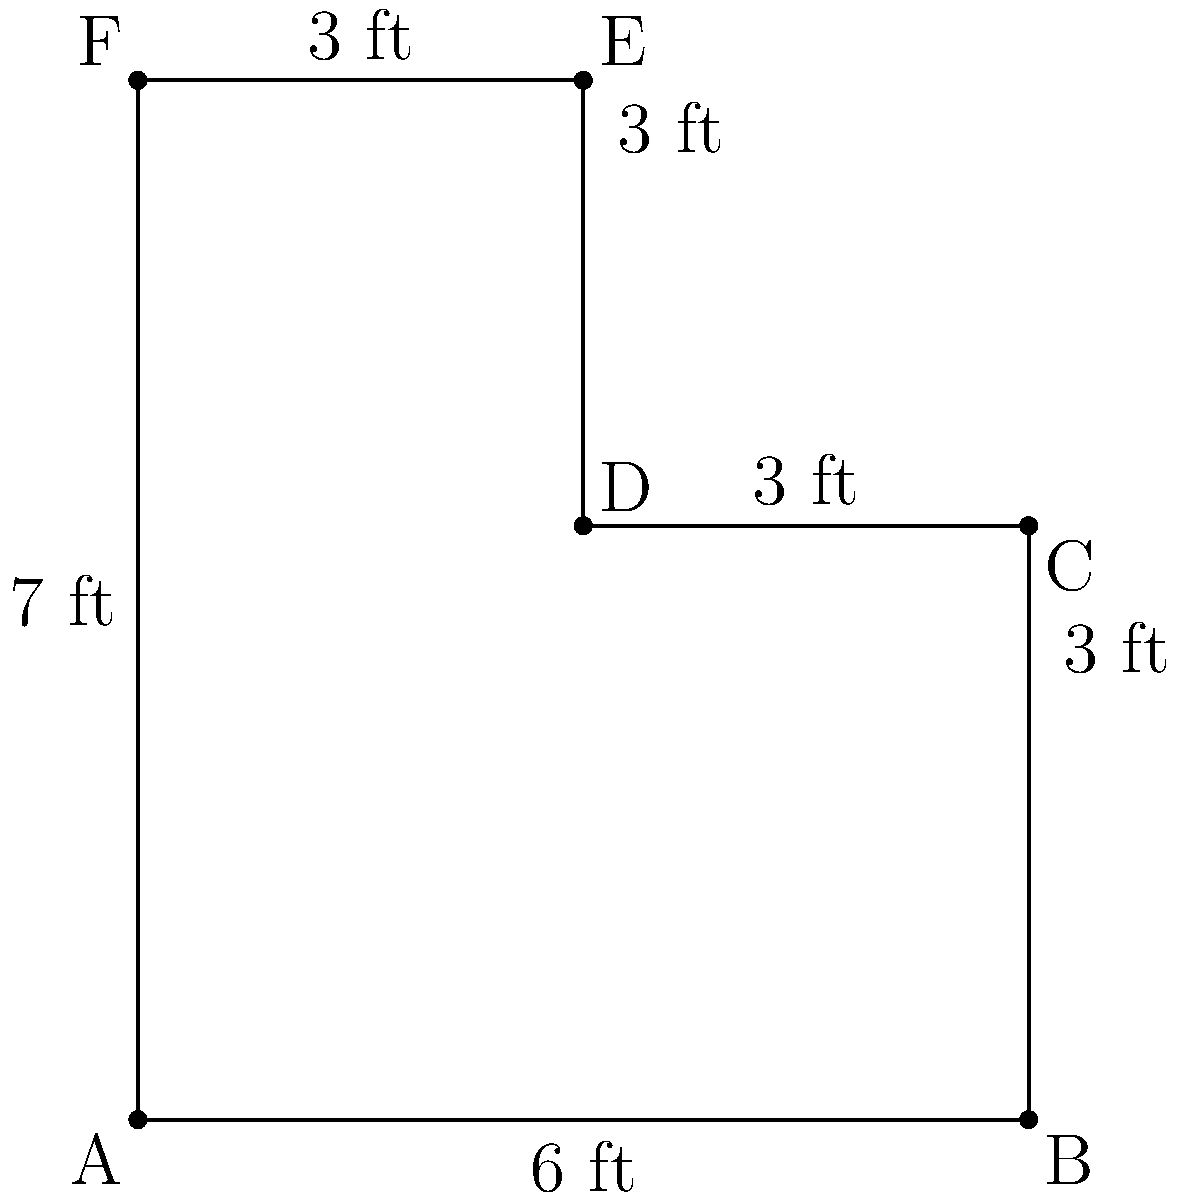You're designing an L-shaped editing desk for your filmography projects. The desk has the dimensions shown in the diagram. Calculate the perimeter of the desk to determine how much LED strip lighting you'll need to outline its edge. To find the perimeter of the L-shaped desk, we need to sum up all the outer edge lengths:

1. Start from point A and move clockwise:
   AB = 6 ft
   BC = 3 ft
   CD = 3 ft
   DE = 3 ft
   EF = 3 ft
   FA = 7 ft

2. Add all these lengths:
   Perimeter = AB + BC + CD + DE + EF + FA
   Perimeter = 6 + 3 + 3 + 3 + 3 + 7

3. Calculate the sum:
   Perimeter = 25 ft

Therefore, you'll need 25 feet of LED strip lighting to outline the entire edge of your L-shaped editing desk.
Answer: 25 ft 